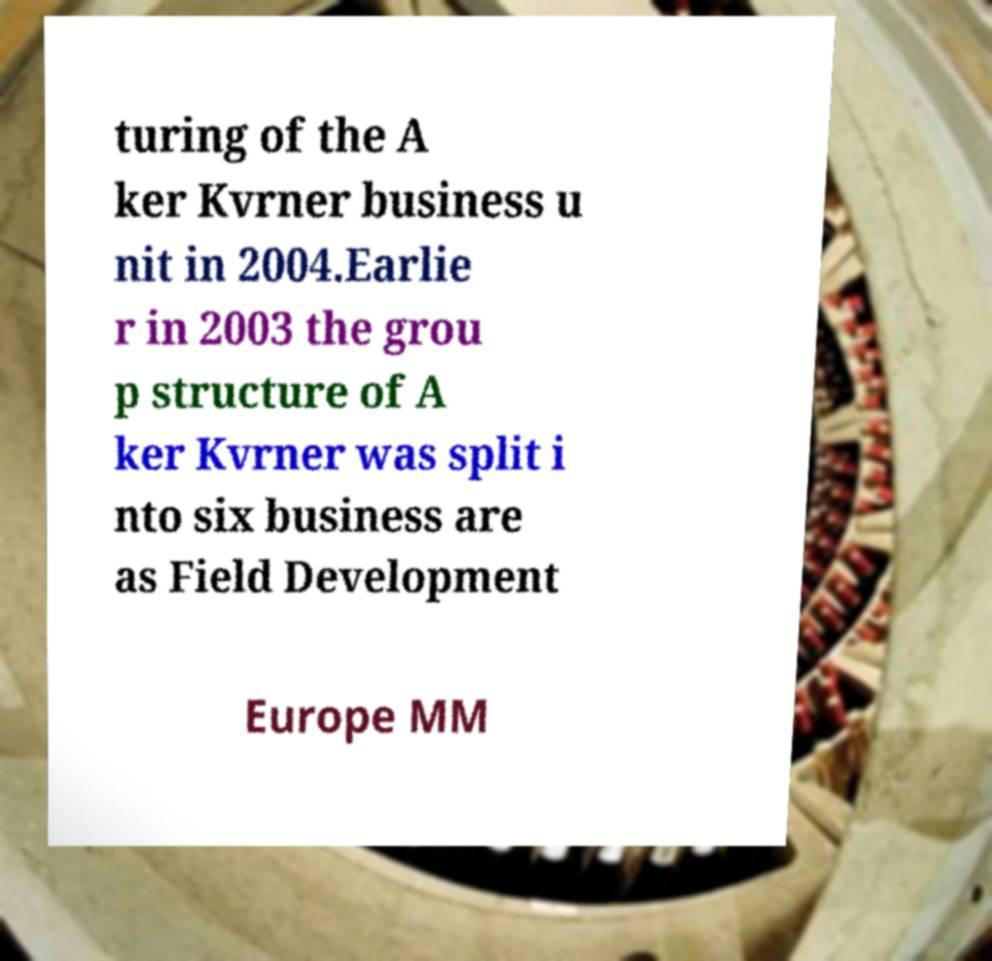For documentation purposes, I need the text within this image transcribed. Could you provide that? turing of the A ker Kvrner business u nit in 2004.Earlie r in 2003 the grou p structure of A ker Kvrner was split i nto six business are as Field Development Europe MM 